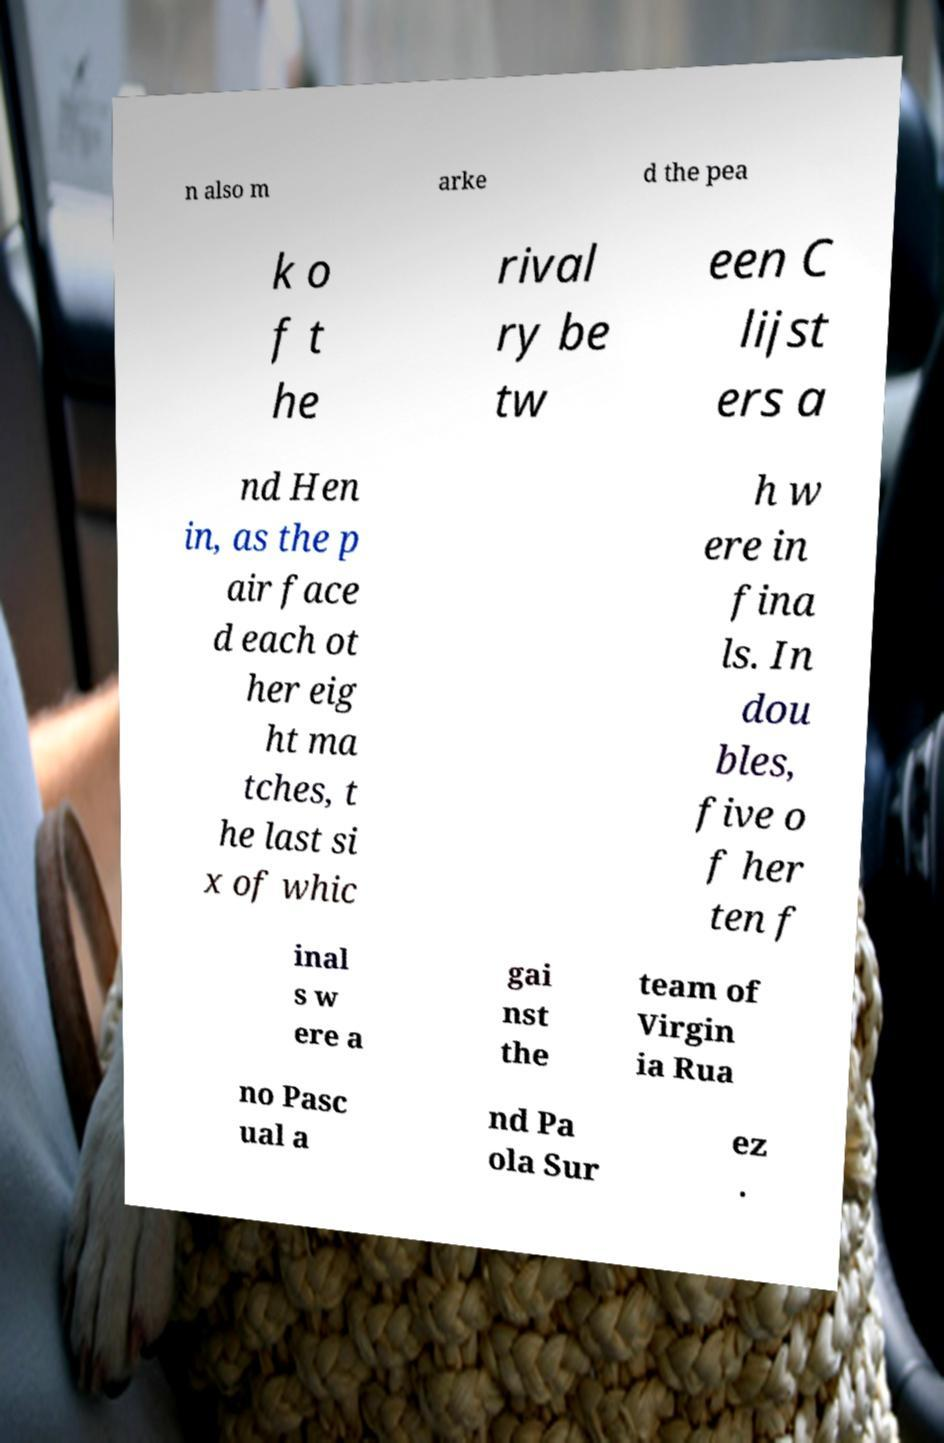Please identify and transcribe the text found in this image. n also m arke d the pea k o f t he rival ry be tw een C lijst ers a nd Hen in, as the p air face d each ot her eig ht ma tches, t he last si x of whic h w ere in fina ls. In dou bles, five o f her ten f inal s w ere a gai nst the team of Virgin ia Rua no Pasc ual a nd Pa ola Sur ez . 